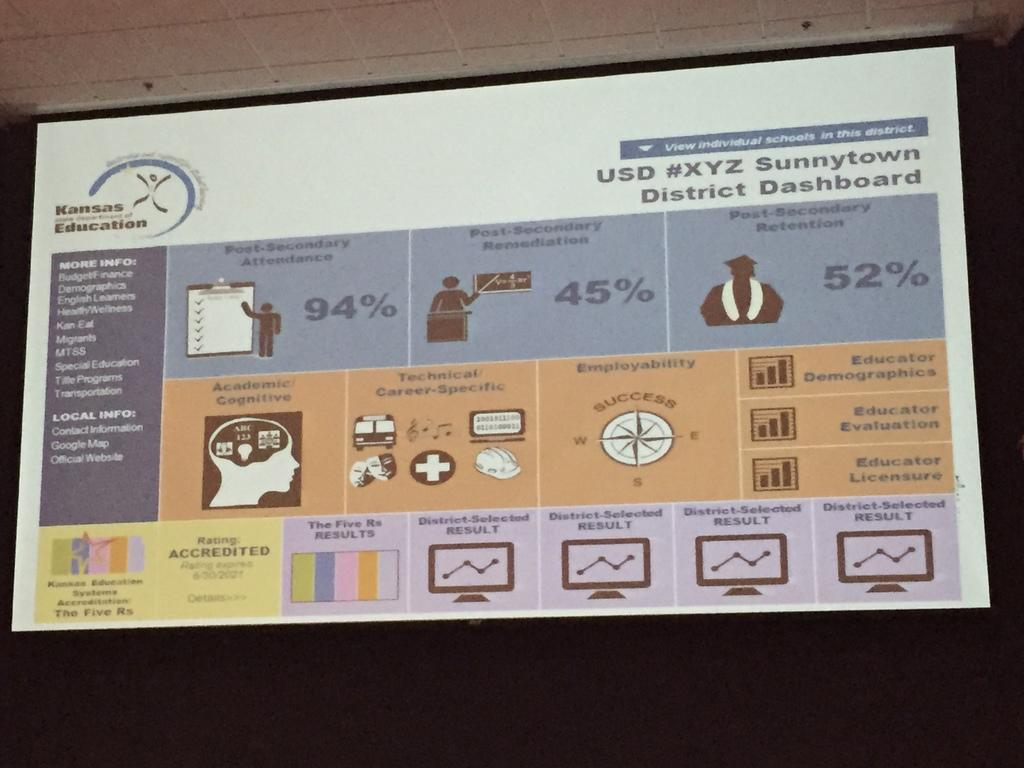<image>
Summarize the visual content of the image. An image depicting USD # XYZ Sunny Town District Dashboard. 